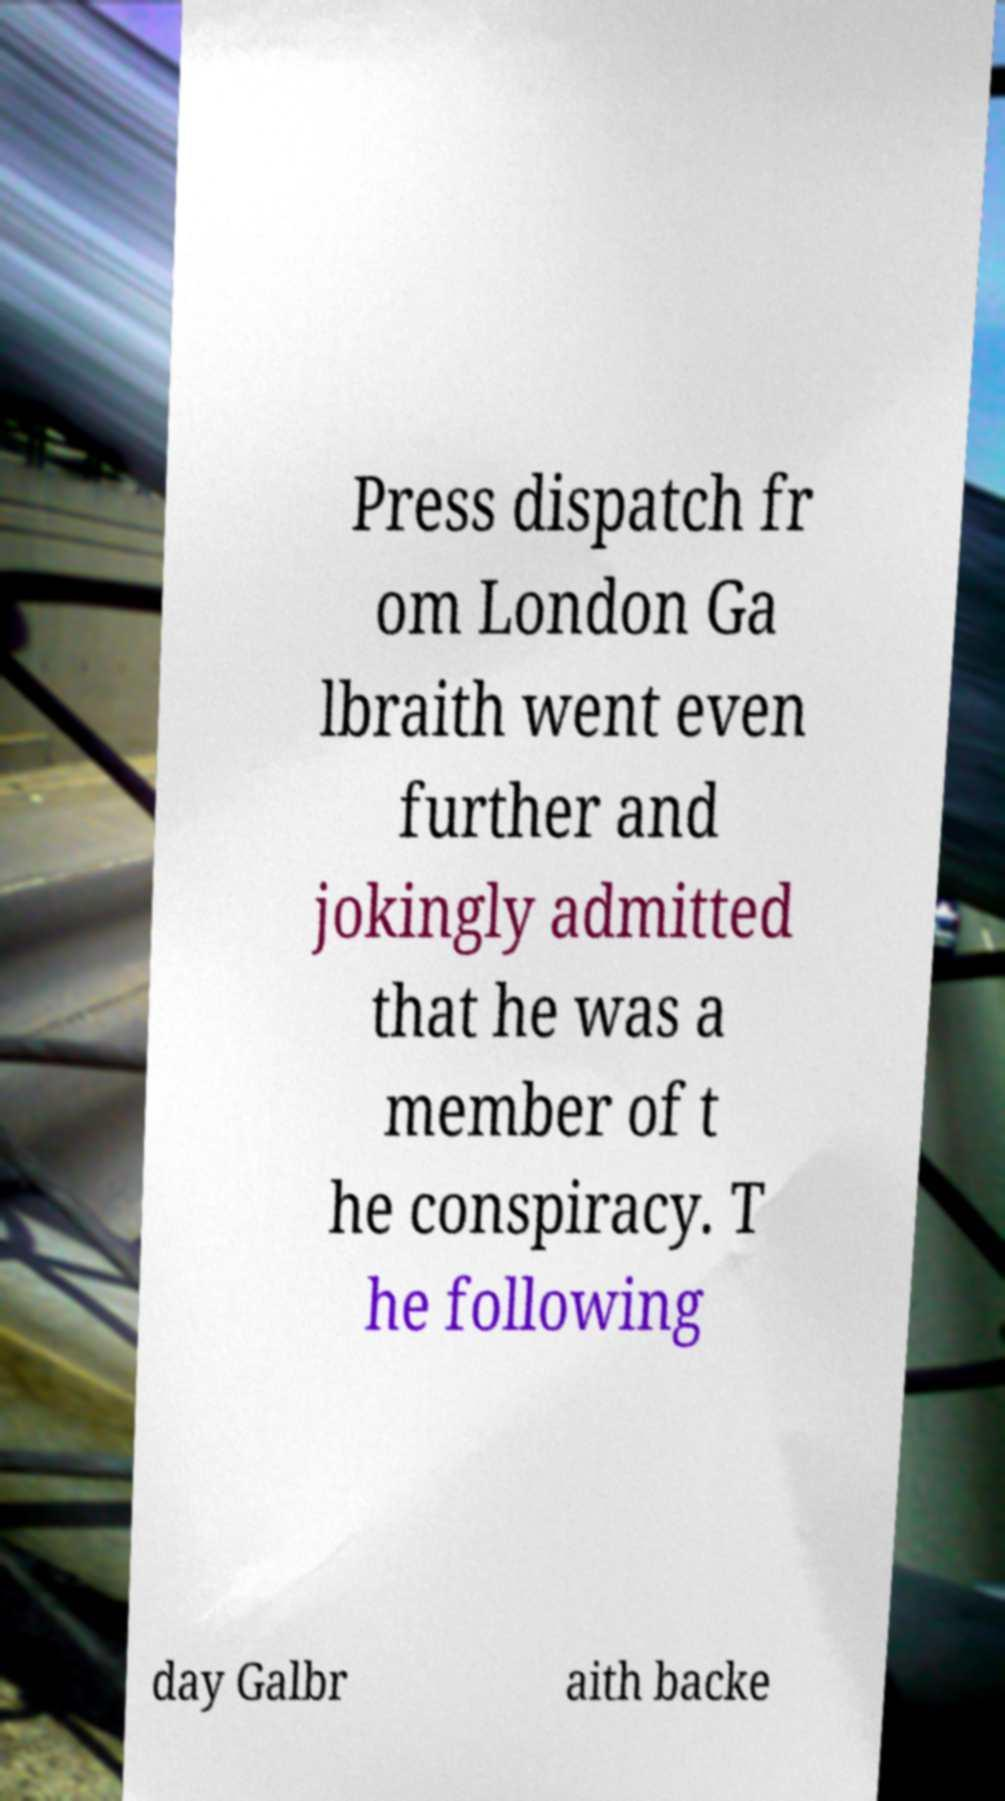Please read and relay the text visible in this image. What does it say? Press dispatch fr om London Ga lbraith went even further and jokingly admitted that he was a member of t he conspiracy. T he following day Galbr aith backe 